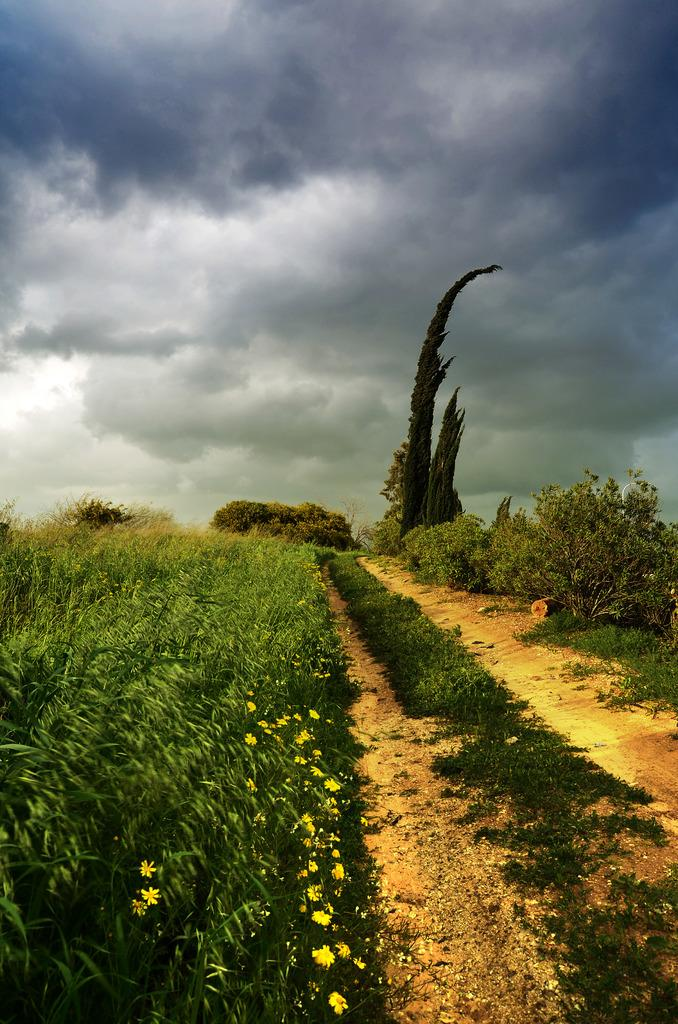What type of vegetation can be seen in the image? There is grass, plants, flowers, and trees in the image. What can be seen in the background of the image? The sky is visible in the background of the image. What type of jewel can be seen in the image? There is no jewel present in the image; it features grass, plants, flowers, trees, and the sky. Is there any lettuce visible in the image? There is no lettuce present in the image. 